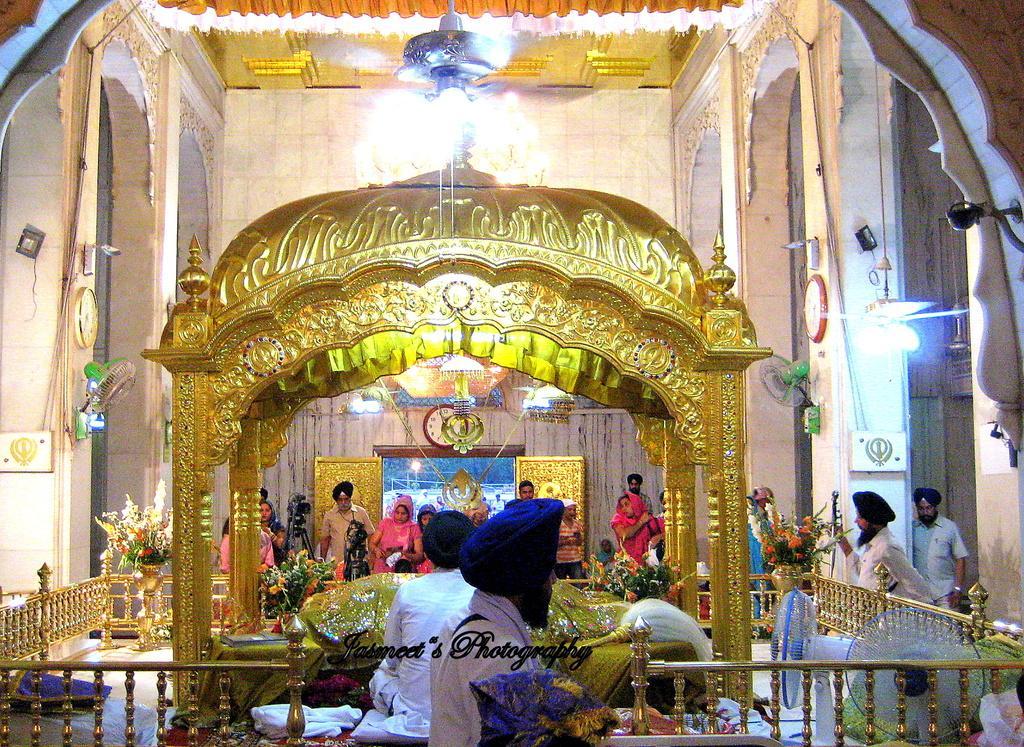Could you give a brief overview of what you see in this image? In this picture there are people those who are standing in the center of the image, it seems to be a temple and there is a boundary at the bottom side of the image. 